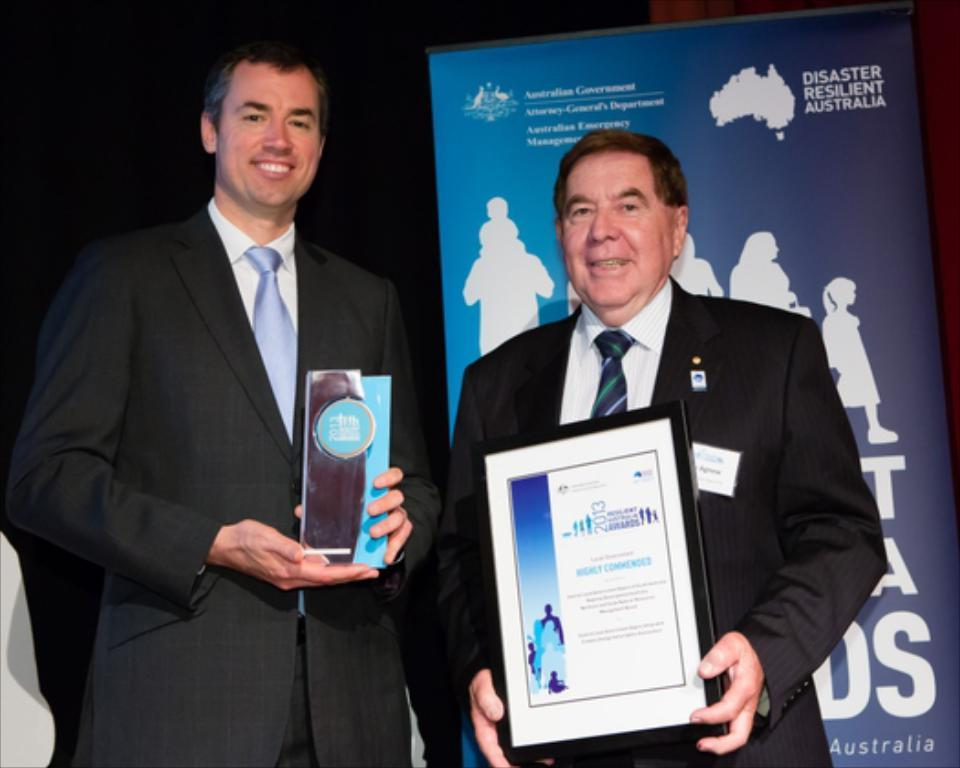How many people are in the image? There are two men in the image. What are the men doing in the image? The men are standing in the image. What are the men holding in their hands? The men are holding mementos in the image. What can be seen in the background of the image? There is a banner in the background of the image. What are the men wearing in the image? The men are wearing black suits in the image. Can you see the mother of the men in the image? There is no mother present in the image; it only features two men. What type of fog can be seen in the image? There is no fog present in the image. 